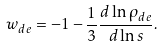Convert formula to latex. <formula><loc_0><loc_0><loc_500><loc_500>w _ { d e } = - 1 - \frac { 1 } { 3 } \frac { d \ln { \rho _ { d e } } } { d \ln { s } } .</formula> 